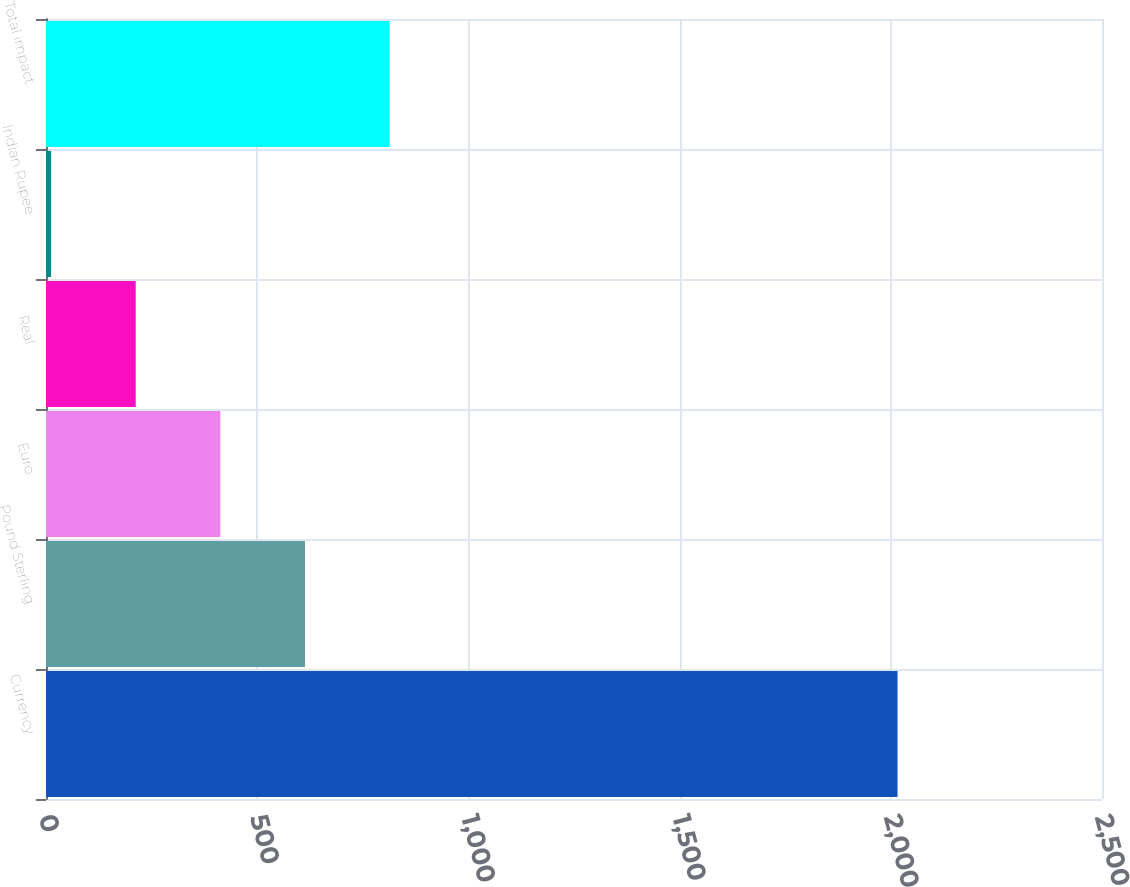<chart> <loc_0><loc_0><loc_500><loc_500><bar_chart><fcel>Currency<fcel>Pound Sterling<fcel>Euro<fcel>Real<fcel>Indian Rupee<fcel>Total impact<nl><fcel>2016<fcel>613.2<fcel>412.8<fcel>212.4<fcel>12<fcel>813.6<nl></chart> 